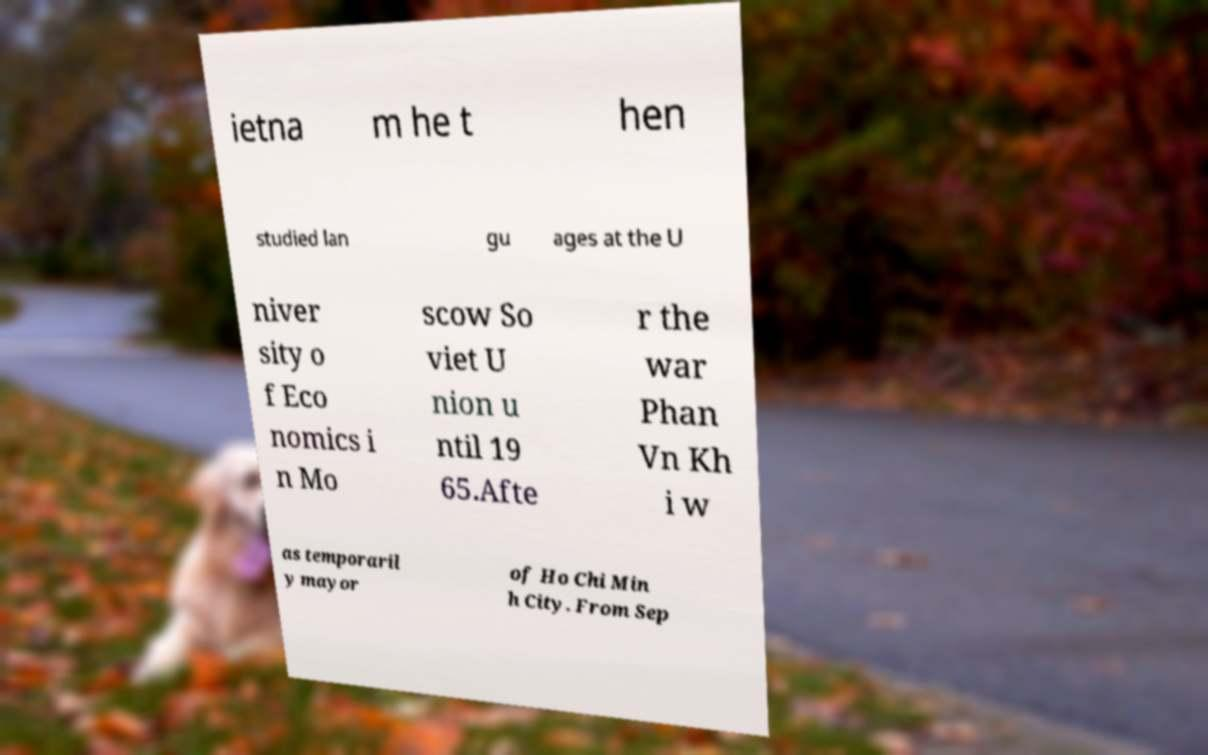What messages or text are displayed in this image? I need them in a readable, typed format. ietna m he t hen studied lan gu ages at the U niver sity o f Eco nomics i n Mo scow So viet U nion u ntil 19 65.Afte r the war Phan Vn Kh i w as temporaril y mayor of Ho Chi Min h City. From Sep 